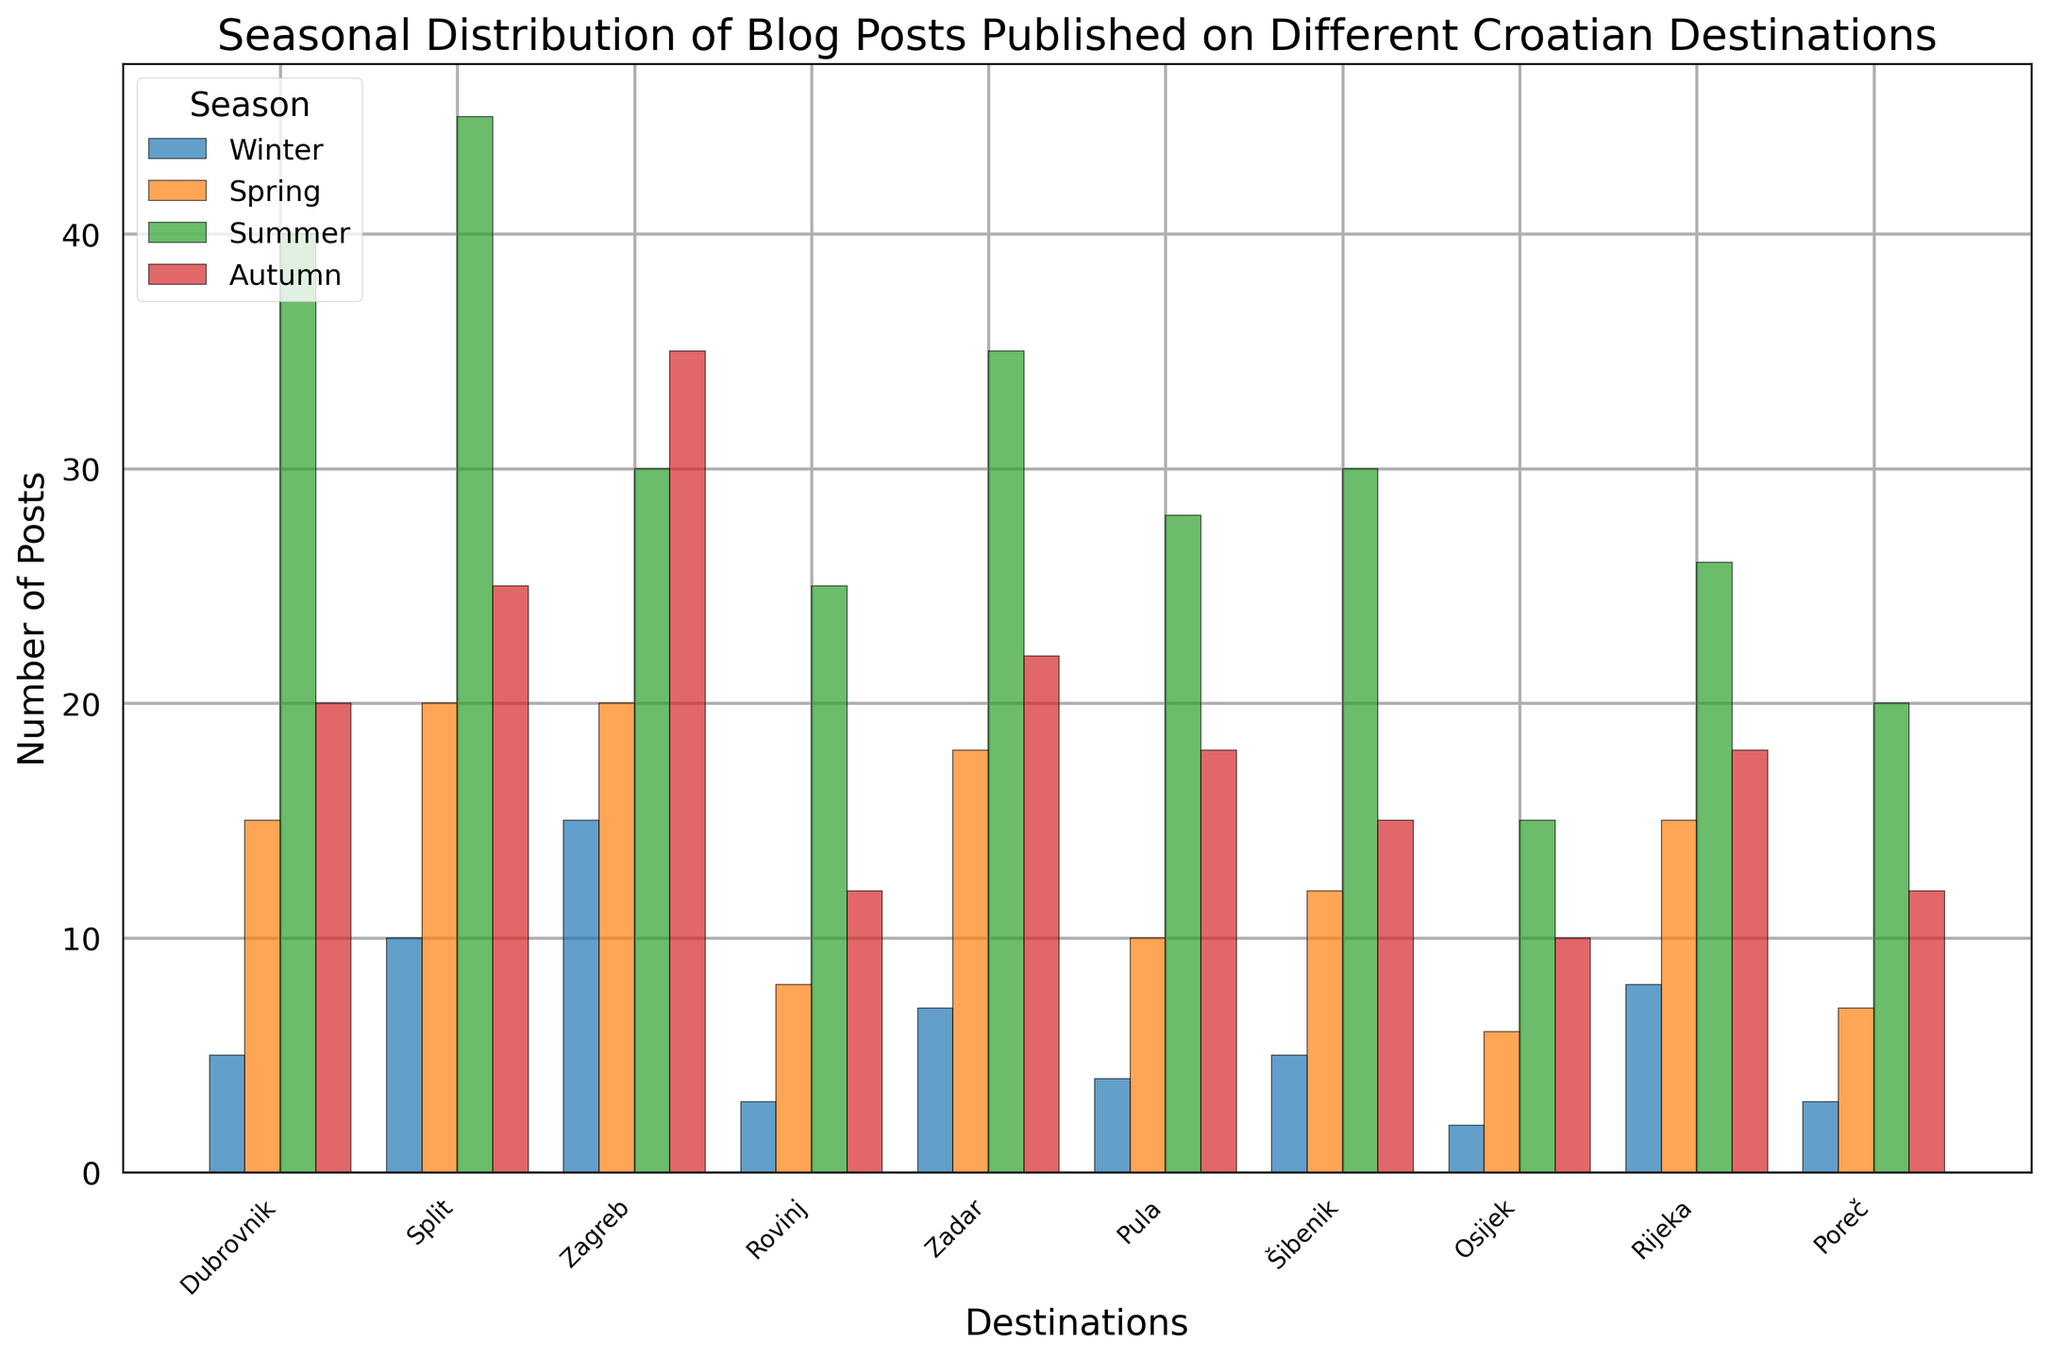Which destination has the highest number of blog posts published in summer? By looking at the height of the bars representing summer for all destinations, the bar for Split is the tallest. This indicates the highest number of blog posts in summer.
Answer: Split What is the total number of blog posts published in Rovinj across all seasons? Add the number of posts for each season in Rovinj: Winter (3) + Spring (8) + Summer (25) + Autumn (12). Therefore, the total is 3 + 8 + 25 + 12 = 48.
Answer: 48 Which season had the highest number of blog posts in Zagreb? By examining the height of the bars for each season in Zagreb, the bar for Autumn is the tallest, indicating that Autumn had the highest number of blog posts.
Answer: Autumn How many more blog posts were published in Dubrovnik in summer compared to winter? Subtract the number of posts in winter from the number of posts in summer for Dubrovnik: Summer (40) - Winter (5) = 35.
Answer: 35 Compare Spring and Autumn blog posts in Pula. Which season had fewer posts, and by how much? By comparing the height of the bars, Spring (10) and Autumn (18), Spring had fewer posts. The difference is 18 - 10 = 8.
Answer: Spring, 8 What is the average number of blog posts published in Šibenik across all seasons? Add the number of posts for each season in Šibenik and divide by the number of seasons: (Winter (5) + Spring (12) + Summer (30) + Autumn (15)) / 4 = (5 + 12 + 30 + 15) / 4 = 62 / 4 = 15.5.
Answer: 15.5 Which destination had the lowest number of blog posts in winter? By checking the heights of the bars for Winter across all destinations, Osijek has the shortest bar, indicating the lowest number of posts.
Answer: Osijek What is the ratio of summer blog posts in Split to Dubrovnik? Divide the number of Summer posts in Split (45) by the number of Summer posts in Dubrovnik (40): 45 / 40 = 1.125.
Answer: 1.125 Which two destinations have the same number of blog posts in any season? By inspecting the heights of the bars, Dubrovnik and Šibenik both have 5 blog posts in Winter.
Answer: Dubrovnik and Šibenik in Winter Compare the total number of blog posts in Split and Zadar across all seasons. Which is higher? Sum the number of posts for each season in Split (10 + 20 + 45 + 25 = 100) and Zadar (7 + 18 + 35 + 22 = 82). Split has more blog posts: 100 is greater than 82.
Answer: Split 